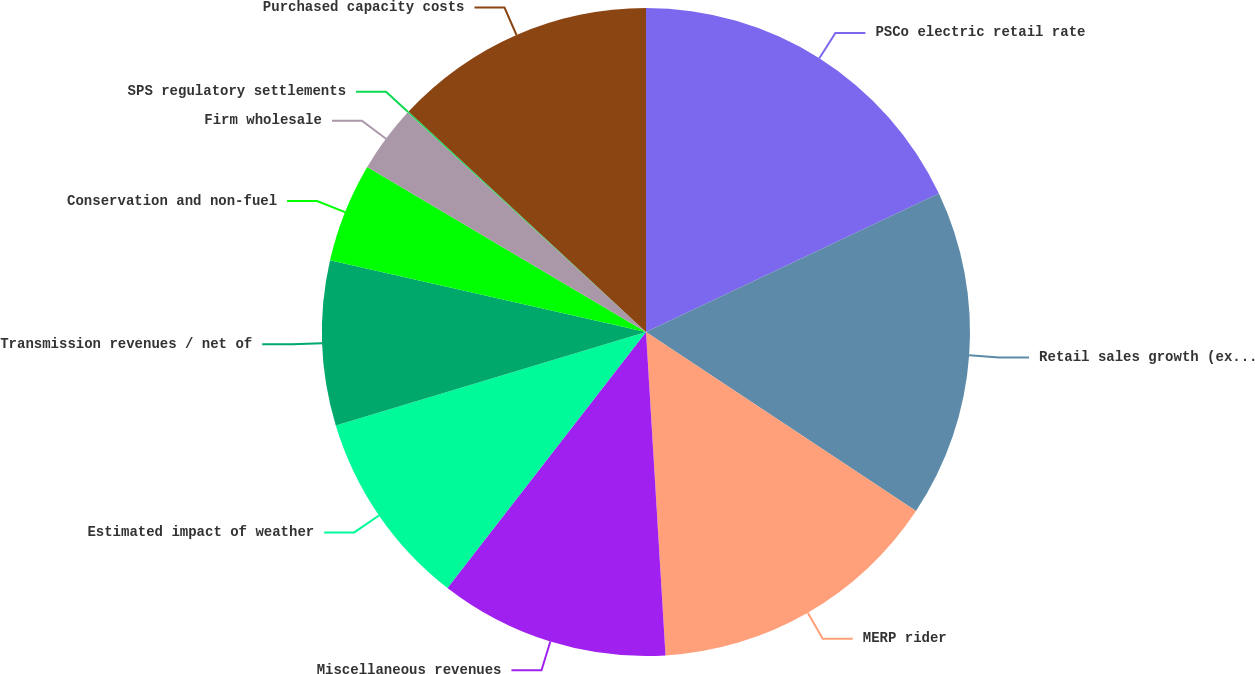Convert chart. <chart><loc_0><loc_0><loc_500><loc_500><pie_chart><fcel>PSCo electric retail rate<fcel>Retail sales growth (excluding<fcel>MERP rider<fcel>Miscellaneous revenues<fcel>Estimated impact of weather<fcel>Transmission revenues / net of<fcel>Conservation and non-fuel<fcel>Firm wholesale<fcel>SPS regulatory settlements<fcel>Purchased capacity costs<nl><fcel>17.97%<fcel>16.35%<fcel>14.72%<fcel>11.46%<fcel>9.84%<fcel>8.21%<fcel>4.96%<fcel>3.33%<fcel>0.07%<fcel>13.09%<nl></chart> 